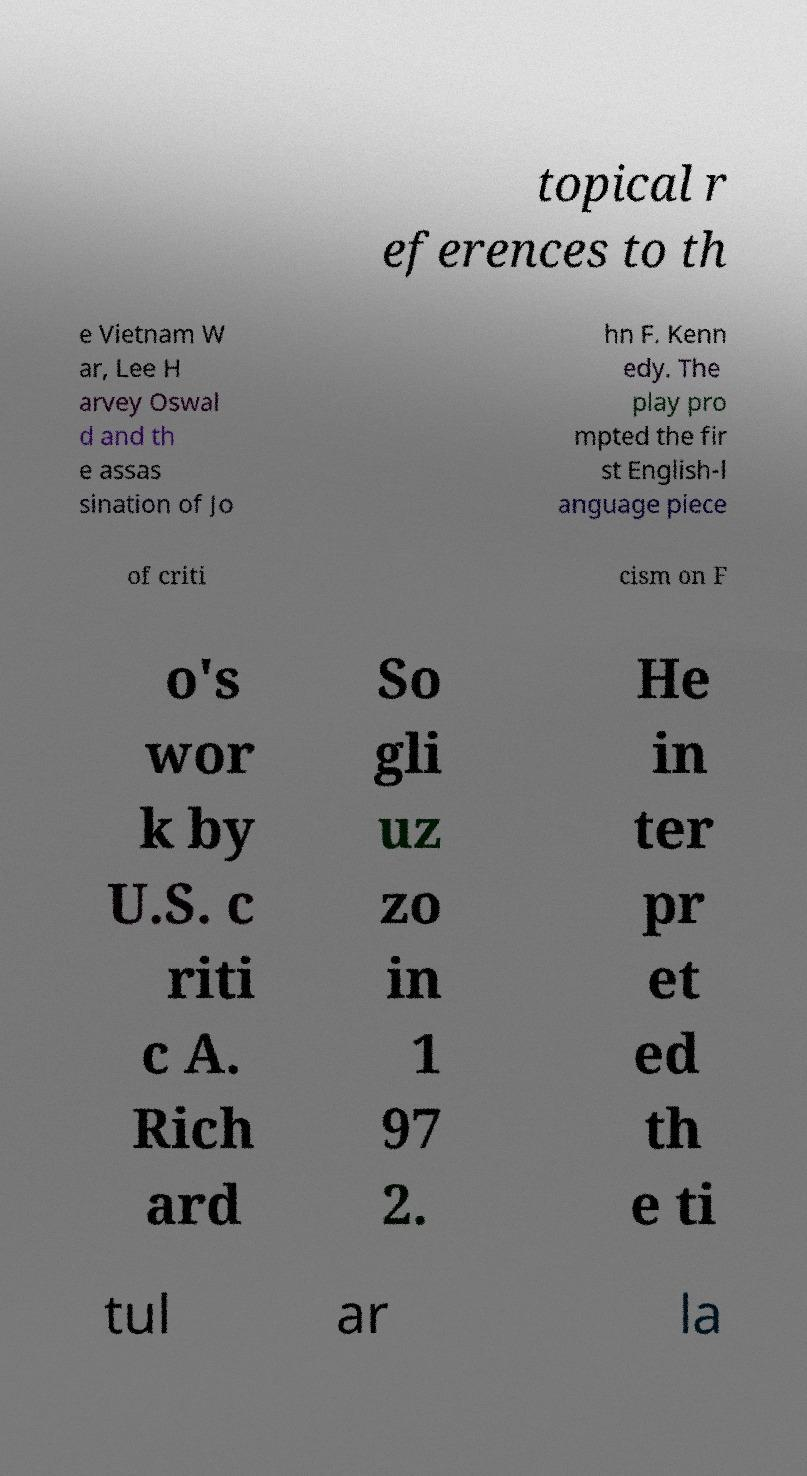Could you extract and type out the text from this image? topical r eferences to th e Vietnam W ar, Lee H arvey Oswal d and th e assas sination of Jo hn F. Kenn edy. The play pro mpted the fir st English-l anguage piece of criti cism on F o's wor k by U.S. c riti c A. Rich ard So gli uz zo in 1 97 2. He in ter pr et ed th e ti tul ar la 